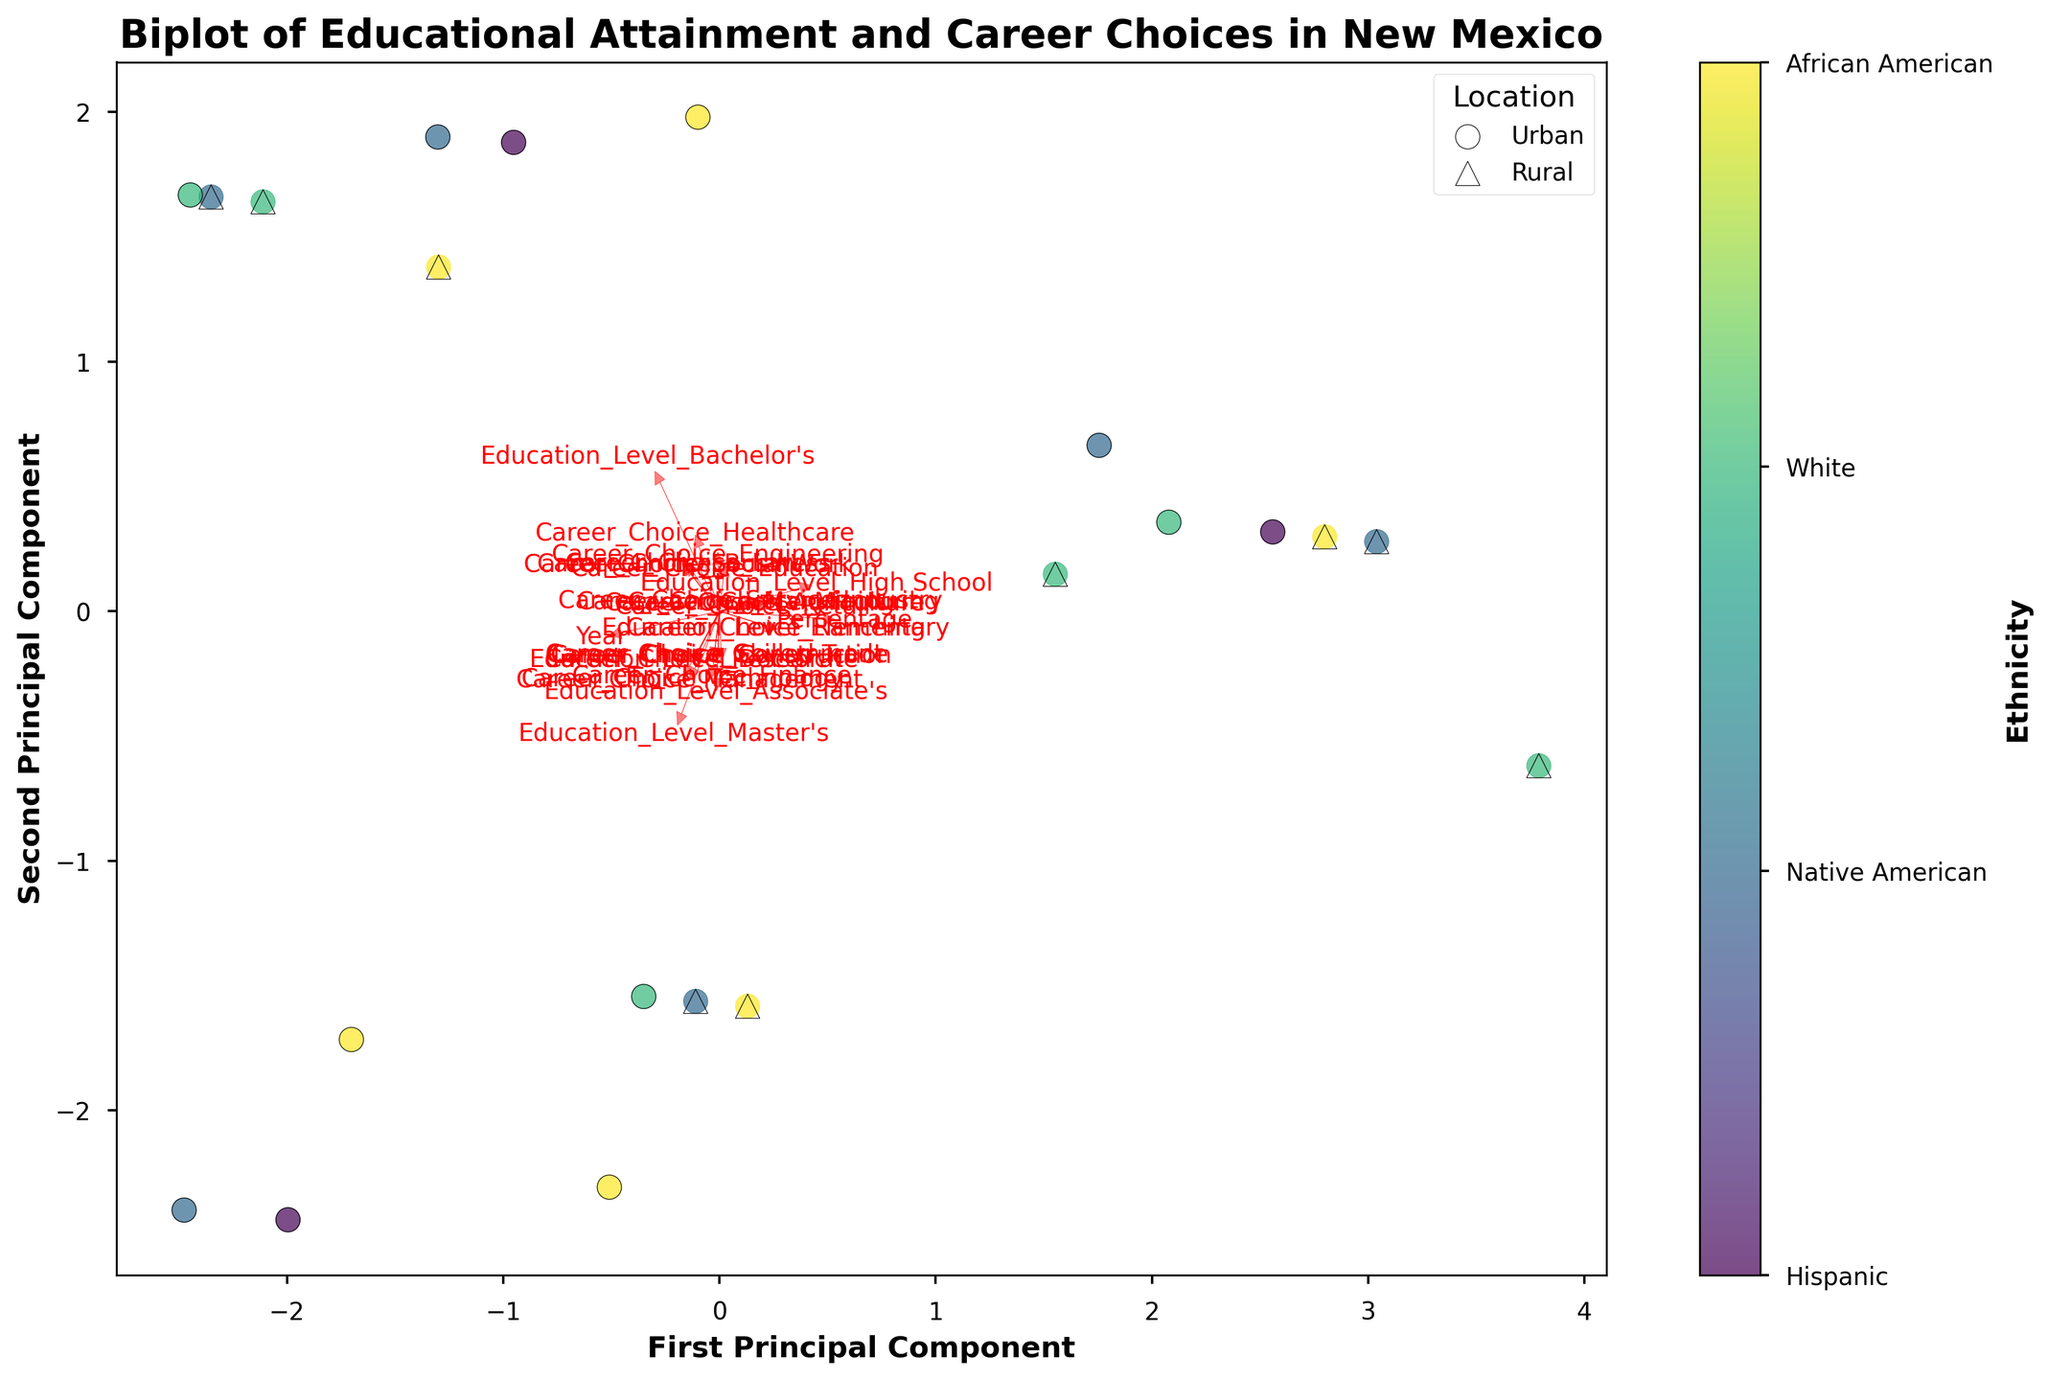What's the title of the plot? The title of the plot is prominently displayed at the top and reads "Biplot of Educational Attainment and Career Choices in New Mexico".
Answer: Biplot of Educational Attainment and Career Choices in New Mexico How many ethnic groups are shown in the plot? The color bar on the right side of the biplot indicates the different ethnic groups, and by counting the unique labels, we can identify four ethnic groups.
Answer: Four Which ethnic group is represented by the highest number of data points in rural areas? By examining the plot with markers, we see that most triangular markers (representing rural areas) correspond to the color assigned to a specific ethnic group. Counting these markers reveals that Hispanic is the ethnic group with the highest number of data points in rural areas.
Answer: Hispanic What career choice is strongly associated with Bachelor's level education for the Hispanic group in urban areas? By looking at the PCA component vectors on the biplot, identified by arrows, we find the vector corresponding to Bachelor's level education and follow its direction. This points toward Healthcare, suggesting a strong association.
Answer: Healthcare Which career choice shows the largest shift in association from the 1920s to 2020 for Native Americans in rural areas? The plot illustrates how different elements are spread over the PCA components. Observing the points labeled for Native American data, the most apparent movement is from the direction of "Ranching" in 1920 towards "Social Work" in 2020.
Answer: Social Work Compare the alignment of education levels between urban and rural areas for White populations. What do you observe? By examining the positions of urban (circle markers) and rural (triangle markers) data points for Whites, we can see urban areas have a higher positioning correlating with higher education levels (Bachelor's, Master's, Doctorate), while rural areas predominantly show High School and Associate's levels further down.
Answer: Higher education levels are more prevalent in urban areas Which principal component has a stronger influence on the distribution of career choices? Observing the arrows (feature vectors), we see which PCA components they align with. If most career choices align more strongly with the horizontal line, the first principal component has a stronger influence. If more align vertically, the second component does. Here, they predominantly align horizontally with the first principal component.
Answer: First principal component What is the trend in educational attainment for African Americans in urban areas from 1920 to 2020? Observing the data points for the African American group in urban areas, represented with circles, we follow them chronologically from the lower positions (High School) upwards through Bachelor's and Master's levels over time, demonstrating an upward trend in educational attainment.
Answer: Increasing 